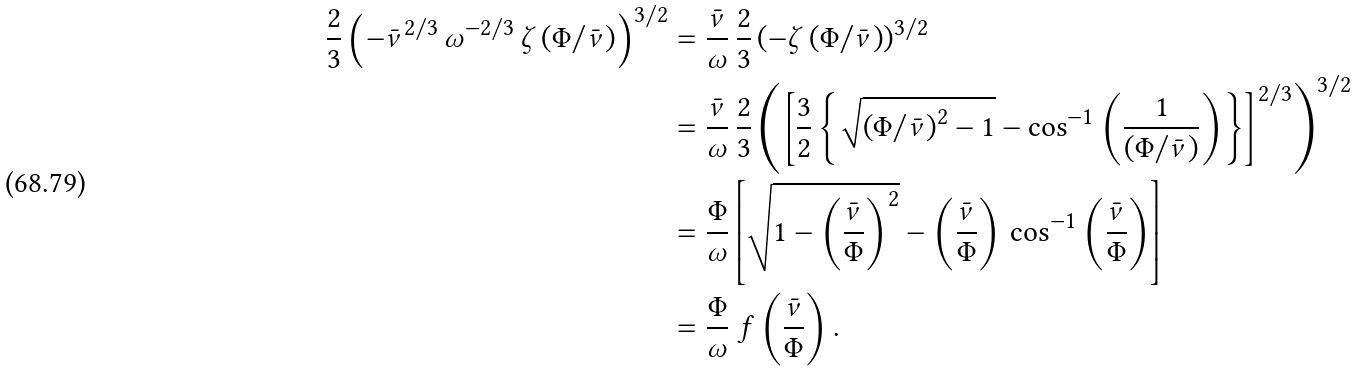<formula> <loc_0><loc_0><loc_500><loc_500>\frac { 2 } { 3 } \left ( - \bar { \nu } ^ { 2 / 3 } \, \omega ^ { - 2 / 3 } \, \zeta \left ( \Phi / \bar { \nu } \right ) \right ) ^ { 3 / 2 } & = \frac { \bar { \nu } } { \omega } \, \frac { 2 } { 3 } \left ( - \zeta \left ( \Phi / \bar { \nu } \right ) \right ) ^ { 3 / 2 } \\ & = \frac { \bar { \nu } } { \omega } \, \frac { 2 } { 3 } \left ( \left [ \frac { 3 } { 2 } \left \{ \sqrt { \left ( \Phi / \bar { \nu } \right ) ^ { 2 } - 1 } - \cos ^ { - 1 } \left ( \frac { 1 } { \left ( \Phi / \bar { \nu } \right ) } \right ) \right \} \right ] ^ { 2 / 3 } \right ) ^ { 3 / 2 } \\ & = \frac { \Phi } { \omega } \left [ \sqrt { 1 - \left ( \frac { \bar { \nu } } { \Phi } \right ) ^ { 2 } } - \left ( \frac { \bar { \nu } } { \Phi } \right ) \, \cos ^ { - 1 } \left ( \frac { \bar { \nu } } { \Phi } \right ) \right ] \\ & = \frac { \Phi } { \omega } \ f \left ( \frac { \bar { \nu } } { \Phi } \right ) .</formula> 